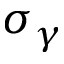<formula> <loc_0><loc_0><loc_500><loc_500>\sigma _ { \gamma }</formula> 